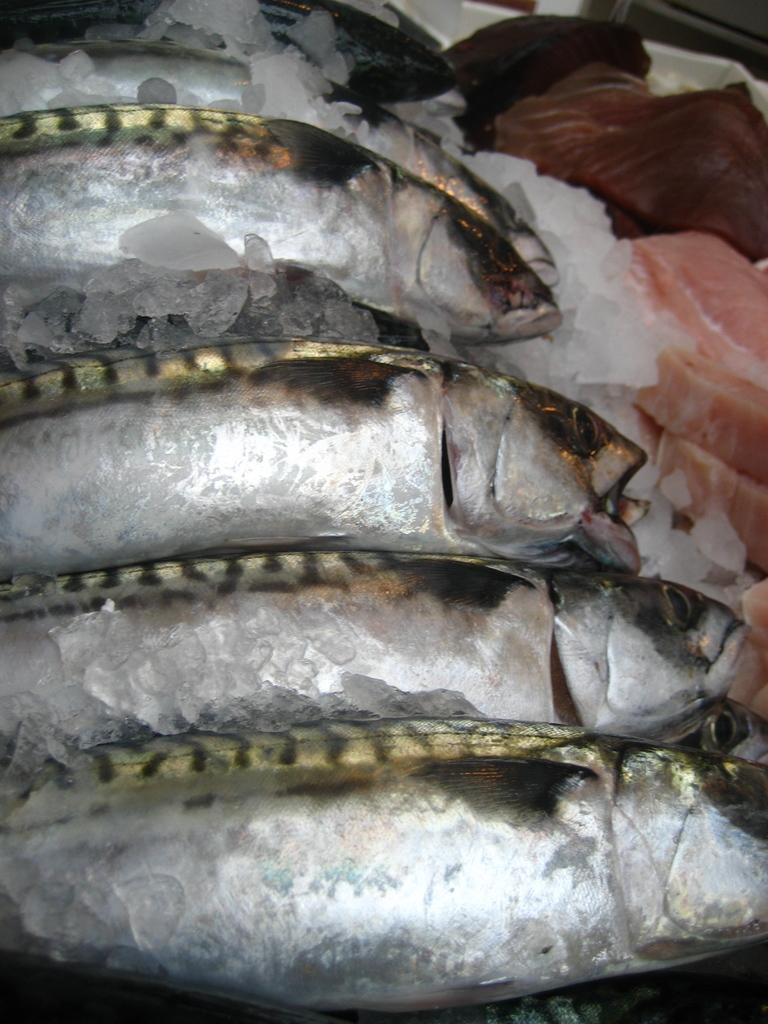What type of animals can be seen in the foreground of the image? There are fishes in the foreground of the image. What is placed on the ice in the foreground of the image? There is meat on the ice in the foreground of the image. What type of wound can be seen on the farmer in the image? There is no farmer present in the image, and therefore no wound can be observed. What type of medical advice can be given by the doctor in the image? There is no doctor present in the image, and therefore no medical advice can be given. 